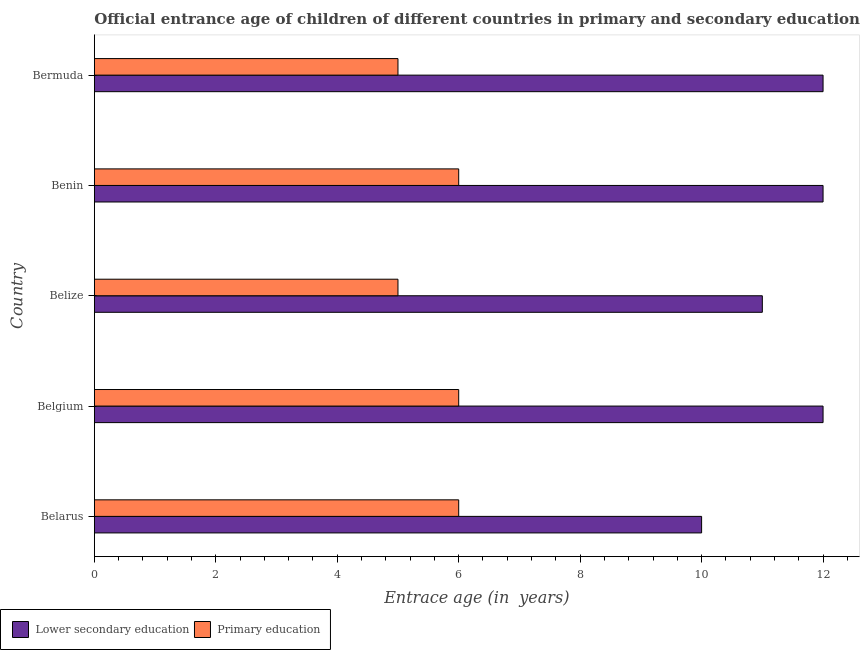How many different coloured bars are there?
Make the answer very short. 2. Are the number of bars per tick equal to the number of legend labels?
Offer a terse response. Yes. How many bars are there on the 3rd tick from the top?
Your answer should be very brief. 2. How many bars are there on the 5th tick from the bottom?
Offer a very short reply. 2. What is the label of the 5th group of bars from the top?
Your answer should be compact. Belarus. What is the entrance age of children in lower secondary education in Belize?
Offer a terse response. 11. Across all countries, what is the maximum entrance age of children in lower secondary education?
Provide a short and direct response. 12. Across all countries, what is the minimum entrance age of chiildren in primary education?
Ensure brevity in your answer.  5. In which country was the entrance age of chiildren in primary education maximum?
Keep it short and to the point. Belarus. In which country was the entrance age of chiildren in primary education minimum?
Keep it short and to the point. Belize. What is the total entrance age of children in lower secondary education in the graph?
Your response must be concise. 57. What is the difference between the entrance age of chiildren in primary education in Belgium and the entrance age of children in lower secondary education in Belize?
Give a very brief answer. -5. What is the average entrance age of chiildren in primary education per country?
Provide a short and direct response. 5.6. What is the difference between the entrance age of chiildren in primary education and entrance age of children in lower secondary education in Belgium?
Offer a terse response. -6. In how many countries, is the entrance age of children in lower secondary education greater than 4 years?
Provide a short and direct response. 5. What is the ratio of the entrance age of chiildren in primary education in Belarus to that in Belgium?
Make the answer very short. 1. Is the difference between the entrance age of chiildren in primary education in Belarus and Benin greater than the difference between the entrance age of children in lower secondary education in Belarus and Benin?
Your response must be concise. Yes. What is the difference between the highest and the lowest entrance age of chiildren in primary education?
Make the answer very short. 1. Is the sum of the entrance age of children in lower secondary education in Benin and Bermuda greater than the maximum entrance age of chiildren in primary education across all countries?
Give a very brief answer. Yes. What does the 1st bar from the bottom in Belize represents?
Give a very brief answer. Lower secondary education. How many bars are there?
Make the answer very short. 10. Are all the bars in the graph horizontal?
Your response must be concise. Yes. How many countries are there in the graph?
Make the answer very short. 5. What is the difference between two consecutive major ticks on the X-axis?
Offer a terse response. 2. Where does the legend appear in the graph?
Your response must be concise. Bottom left. How many legend labels are there?
Keep it short and to the point. 2. What is the title of the graph?
Provide a succinct answer. Official entrance age of children of different countries in primary and secondary education. What is the label or title of the X-axis?
Make the answer very short. Entrace age (in  years). What is the label or title of the Y-axis?
Your response must be concise. Country. What is the Entrace age (in  years) in Lower secondary education in Belarus?
Offer a very short reply. 10. What is the Entrace age (in  years) in Lower secondary education in Belgium?
Your answer should be compact. 12. What is the Entrace age (in  years) of Lower secondary education in Belize?
Offer a terse response. 11. What is the Entrace age (in  years) of Lower secondary education in Benin?
Keep it short and to the point. 12. What is the Entrace age (in  years) of Primary education in Benin?
Make the answer very short. 6. What is the Entrace age (in  years) in Lower secondary education in Bermuda?
Your answer should be compact. 12. What is the Entrace age (in  years) in Primary education in Bermuda?
Your response must be concise. 5. Across all countries, what is the maximum Entrace age (in  years) in Primary education?
Your answer should be compact. 6. Across all countries, what is the minimum Entrace age (in  years) in Lower secondary education?
Provide a succinct answer. 10. What is the total Entrace age (in  years) in Primary education in the graph?
Your answer should be compact. 28. What is the difference between the Entrace age (in  years) of Primary education in Belarus and that in Belize?
Provide a succinct answer. 1. What is the difference between the Entrace age (in  years) of Lower secondary education in Belgium and that in Belize?
Provide a succinct answer. 1. What is the difference between the Entrace age (in  years) in Primary education in Belgium and that in Benin?
Ensure brevity in your answer.  0. What is the difference between the Entrace age (in  years) of Primary education in Belgium and that in Bermuda?
Make the answer very short. 1. What is the difference between the Entrace age (in  years) of Lower secondary education in Belize and that in Benin?
Give a very brief answer. -1. What is the difference between the Entrace age (in  years) in Lower secondary education in Benin and that in Bermuda?
Provide a succinct answer. 0. What is the difference between the Entrace age (in  years) of Primary education in Benin and that in Bermuda?
Keep it short and to the point. 1. What is the difference between the Entrace age (in  years) in Lower secondary education in Belarus and the Entrace age (in  years) in Primary education in Belgium?
Provide a succinct answer. 4. What is the difference between the Entrace age (in  years) in Lower secondary education in Belarus and the Entrace age (in  years) in Primary education in Benin?
Offer a very short reply. 4. What is the difference between the Entrace age (in  years) in Lower secondary education in Belgium and the Entrace age (in  years) in Primary education in Belize?
Give a very brief answer. 7. What is the difference between the Entrace age (in  years) in Lower secondary education in Belgium and the Entrace age (in  years) in Primary education in Benin?
Give a very brief answer. 6. What is the difference between the Entrace age (in  years) in Lower secondary education in Belize and the Entrace age (in  years) in Primary education in Benin?
Ensure brevity in your answer.  5. What is the difference between the Entrace age (in  years) of Lower secondary education in Benin and the Entrace age (in  years) of Primary education in Bermuda?
Keep it short and to the point. 7. What is the average Entrace age (in  years) of Primary education per country?
Give a very brief answer. 5.6. What is the difference between the Entrace age (in  years) of Lower secondary education and Entrace age (in  years) of Primary education in Belgium?
Offer a very short reply. 6. What is the ratio of the Entrace age (in  years) of Lower secondary education in Belarus to that in Belgium?
Ensure brevity in your answer.  0.83. What is the ratio of the Entrace age (in  years) of Lower secondary education in Belarus to that in Belize?
Provide a short and direct response. 0.91. What is the ratio of the Entrace age (in  years) of Lower secondary education in Belarus to that in Benin?
Provide a short and direct response. 0.83. What is the ratio of the Entrace age (in  years) of Primary education in Belarus to that in Benin?
Your answer should be compact. 1. What is the ratio of the Entrace age (in  years) of Primary education in Belarus to that in Bermuda?
Make the answer very short. 1.2. What is the ratio of the Entrace age (in  years) of Lower secondary education in Belgium to that in Benin?
Your answer should be compact. 1. What is the ratio of the Entrace age (in  years) of Primary education in Belgium to that in Benin?
Offer a very short reply. 1. What is the ratio of the Entrace age (in  years) of Primary education in Belgium to that in Bermuda?
Offer a terse response. 1.2. What is the ratio of the Entrace age (in  years) of Primary education in Belize to that in Benin?
Your answer should be compact. 0.83. What is the ratio of the Entrace age (in  years) of Primary education in Belize to that in Bermuda?
Provide a short and direct response. 1. What is the ratio of the Entrace age (in  years) of Primary education in Benin to that in Bermuda?
Offer a terse response. 1.2. What is the difference between the highest and the second highest Entrace age (in  years) of Lower secondary education?
Keep it short and to the point. 0. What is the difference between the highest and the lowest Entrace age (in  years) in Lower secondary education?
Your response must be concise. 2. What is the difference between the highest and the lowest Entrace age (in  years) in Primary education?
Provide a short and direct response. 1. 